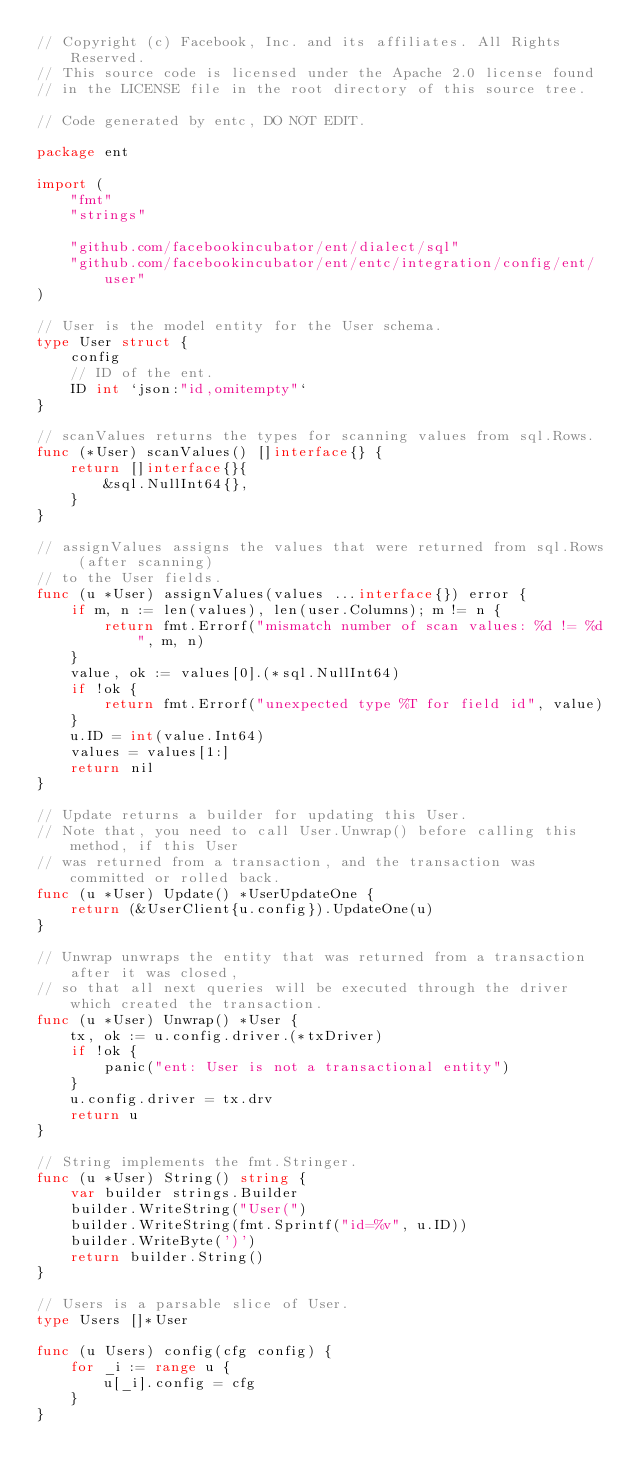Convert code to text. <code><loc_0><loc_0><loc_500><loc_500><_Go_>// Copyright (c) Facebook, Inc. and its affiliates. All Rights Reserved.
// This source code is licensed under the Apache 2.0 license found
// in the LICENSE file in the root directory of this source tree.

// Code generated by entc, DO NOT EDIT.

package ent

import (
	"fmt"
	"strings"

	"github.com/facebookincubator/ent/dialect/sql"
	"github.com/facebookincubator/ent/entc/integration/config/ent/user"
)

// User is the model entity for the User schema.
type User struct {
	config
	// ID of the ent.
	ID int `json:"id,omitempty"`
}

// scanValues returns the types for scanning values from sql.Rows.
func (*User) scanValues() []interface{} {
	return []interface{}{
		&sql.NullInt64{},
	}
}

// assignValues assigns the values that were returned from sql.Rows (after scanning)
// to the User fields.
func (u *User) assignValues(values ...interface{}) error {
	if m, n := len(values), len(user.Columns); m != n {
		return fmt.Errorf("mismatch number of scan values: %d != %d", m, n)
	}
	value, ok := values[0].(*sql.NullInt64)
	if !ok {
		return fmt.Errorf("unexpected type %T for field id", value)
	}
	u.ID = int(value.Int64)
	values = values[1:]
	return nil
}

// Update returns a builder for updating this User.
// Note that, you need to call User.Unwrap() before calling this method, if this User
// was returned from a transaction, and the transaction was committed or rolled back.
func (u *User) Update() *UserUpdateOne {
	return (&UserClient{u.config}).UpdateOne(u)
}

// Unwrap unwraps the entity that was returned from a transaction after it was closed,
// so that all next queries will be executed through the driver which created the transaction.
func (u *User) Unwrap() *User {
	tx, ok := u.config.driver.(*txDriver)
	if !ok {
		panic("ent: User is not a transactional entity")
	}
	u.config.driver = tx.drv
	return u
}

// String implements the fmt.Stringer.
func (u *User) String() string {
	var builder strings.Builder
	builder.WriteString("User(")
	builder.WriteString(fmt.Sprintf("id=%v", u.ID))
	builder.WriteByte(')')
	return builder.String()
}

// Users is a parsable slice of User.
type Users []*User

func (u Users) config(cfg config) {
	for _i := range u {
		u[_i].config = cfg
	}
}
</code> 